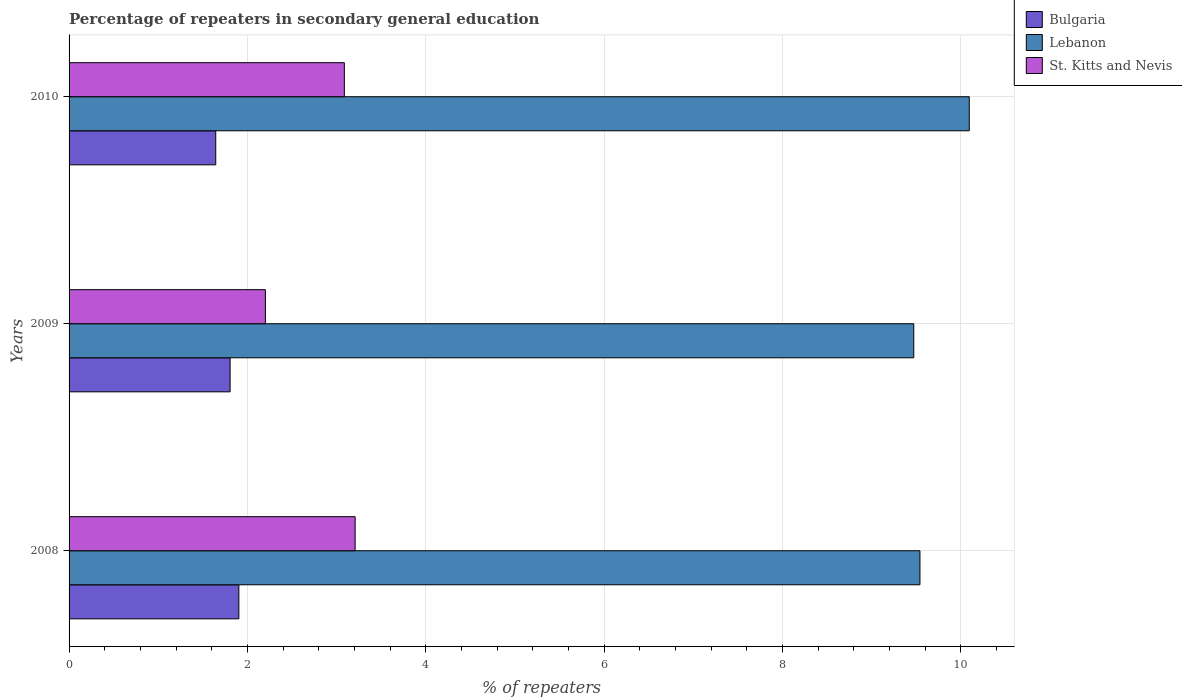Are the number of bars per tick equal to the number of legend labels?
Your answer should be compact. Yes. Are the number of bars on each tick of the Y-axis equal?
Your answer should be compact. Yes. What is the percentage of repeaters in secondary general education in Lebanon in 2008?
Ensure brevity in your answer.  9.54. Across all years, what is the maximum percentage of repeaters in secondary general education in Lebanon?
Your response must be concise. 10.09. Across all years, what is the minimum percentage of repeaters in secondary general education in Lebanon?
Offer a terse response. 9.47. In which year was the percentage of repeaters in secondary general education in Lebanon maximum?
Ensure brevity in your answer.  2010. In which year was the percentage of repeaters in secondary general education in Lebanon minimum?
Your answer should be very brief. 2009. What is the total percentage of repeaters in secondary general education in St. Kitts and Nevis in the graph?
Offer a very short reply. 8.5. What is the difference between the percentage of repeaters in secondary general education in Lebanon in 2008 and that in 2010?
Make the answer very short. -0.55. What is the difference between the percentage of repeaters in secondary general education in Lebanon in 2010 and the percentage of repeaters in secondary general education in St. Kitts and Nevis in 2009?
Provide a succinct answer. 7.89. What is the average percentage of repeaters in secondary general education in Bulgaria per year?
Provide a short and direct response. 1.78. In the year 2009, what is the difference between the percentage of repeaters in secondary general education in Lebanon and percentage of repeaters in secondary general education in Bulgaria?
Your response must be concise. 7.67. What is the ratio of the percentage of repeaters in secondary general education in Bulgaria in 2009 to that in 2010?
Keep it short and to the point. 1.1. Is the percentage of repeaters in secondary general education in Bulgaria in 2009 less than that in 2010?
Provide a short and direct response. No. What is the difference between the highest and the second highest percentage of repeaters in secondary general education in Bulgaria?
Provide a succinct answer. 0.1. What is the difference between the highest and the lowest percentage of repeaters in secondary general education in Lebanon?
Your answer should be compact. 0.62. In how many years, is the percentage of repeaters in secondary general education in St. Kitts and Nevis greater than the average percentage of repeaters in secondary general education in St. Kitts and Nevis taken over all years?
Your answer should be very brief. 2. Is the sum of the percentage of repeaters in secondary general education in Bulgaria in 2008 and 2009 greater than the maximum percentage of repeaters in secondary general education in Lebanon across all years?
Give a very brief answer. No. What does the 3rd bar from the top in 2010 represents?
Your response must be concise. Bulgaria. What does the 3rd bar from the bottom in 2008 represents?
Offer a very short reply. St. Kitts and Nevis. Is it the case that in every year, the sum of the percentage of repeaters in secondary general education in Bulgaria and percentage of repeaters in secondary general education in Lebanon is greater than the percentage of repeaters in secondary general education in St. Kitts and Nevis?
Keep it short and to the point. Yes. How many bars are there?
Your answer should be compact. 9. Are all the bars in the graph horizontal?
Provide a succinct answer. Yes. Are the values on the major ticks of X-axis written in scientific E-notation?
Provide a succinct answer. No. Does the graph contain any zero values?
Make the answer very short. No. Where does the legend appear in the graph?
Offer a terse response. Top right. What is the title of the graph?
Give a very brief answer. Percentage of repeaters in secondary general education. What is the label or title of the X-axis?
Offer a terse response. % of repeaters. What is the label or title of the Y-axis?
Make the answer very short. Years. What is the % of repeaters of Bulgaria in 2008?
Your response must be concise. 1.9. What is the % of repeaters in Lebanon in 2008?
Offer a terse response. 9.54. What is the % of repeaters in St. Kitts and Nevis in 2008?
Make the answer very short. 3.21. What is the % of repeaters in Bulgaria in 2009?
Give a very brief answer. 1.81. What is the % of repeaters in Lebanon in 2009?
Your response must be concise. 9.47. What is the % of repeaters in St. Kitts and Nevis in 2009?
Make the answer very short. 2.2. What is the % of repeaters of Bulgaria in 2010?
Give a very brief answer. 1.64. What is the % of repeaters of Lebanon in 2010?
Provide a succinct answer. 10.09. What is the % of repeaters of St. Kitts and Nevis in 2010?
Make the answer very short. 3.09. Across all years, what is the maximum % of repeaters of Bulgaria?
Offer a very short reply. 1.9. Across all years, what is the maximum % of repeaters in Lebanon?
Give a very brief answer. 10.09. Across all years, what is the maximum % of repeaters of St. Kitts and Nevis?
Make the answer very short. 3.21. Across all years, what is the minimum % of repeaters in Bulgaria?
Your answer should be compact. 1.64. Across all years, what is the minimum % of repeaters in Lebanon?
Your answer should be compact. 9.47. Across all years, what is the minimum % of repeaters in St. Kitts and Nevis?
Your answer should be very brief. 2.2. What is the total % of repeaters in Bulgaria in the graph?
Your answer should be very brief. 5.35. What is the total % of repeaters in Lebanon in the graph?
Provide a succinct answer. 29.11. What is the total % of repeaters of St. Kitts and Nevis in the graph?
Your answer should be compact. 8.5. What is the difference between the % of repeaters in Bulgaria in 2008 and that in 2009?
Your response must be concise. 0.1. What is the difference between the % of repeaters of Lebanon in 2008 and that in 2009?
Keep it short and to the point. 0.07. What is the difference between the % of repeaters in Bulgaria in 2008 and that in 2010?
Give a very brief answer. 0.26. What is the difference between the % of repeaters of Lebanon in 2008 and that in 2010?
Your answer should be very brief. -0.55. What is the difference between the % of repeaters in St. Kitts and Nevis in 2008 and that in 2010?
Keep it short and to the point. 0.12. What is the difference between the % of repeaters in Bulgaria in 2009 and that in 2010?
Keep it short and to the point. 0.16. What is the difference between the % of repeaters in Lebanon in 2009 and that in 2010?
Ensure brevity in your answer.  -0.62. What is the difference between the % of repeaters of St. Kitts and Nevis in 2009 and that in 2010?
Ensure brevity in your answer.  -0.89. What is the difference between the % of repeaters in Bulgaria in 2008 and the % of repeaters in Lebanon in 2009?
Provide a succinct answer. -7.57. What is the difference between the % of repeaters of Bulgaria in 2008 and the % of repeaters of St. Kitts and Nevis in 2009?
Provide a succinct answer. -0.3. What is the difference between the % of repeaters of Lebanon in 2008 and the % of repeaters of St. Kitts and Nevis in 2009?
Your response must be concise. 7.34. What is the difference between the % of repeaters in Bulgaria in 2008 and the % of repeaters in Lebanon in 2010?
Your response must be concise. -8.19. What is the difference between the % of repeaters in Bulgaria in 2008 and the % of repeaters in St. Kitts and Nevis in 2010?
Your answer should be compact. -1.18. What is the difference between the % of repeaters of Lebanon in 2008 and the % of repeaters of St. Kitts and Nevis in 2010?
Ensure brevity in your answer.  6.45. What is the difference between the % of repeaters of Bulgaria in 2009 and the % of repeaters of Lebanon in 2010?
Your response must be concise. -8.29. What is the difference between the % of repeaters of Bulgaria in 2009 and the % of repeaters of St. Kitts and Nevis in 2010?
Your response must be concise. -1.28. What is the difference between the % of repeaters of Lebanon in 2009 and the % of repeaters of St. Kitts and Nevis in 2010?
Provide a short and direct response. 6.38. What is the average % of repeaters in Bulgaria per year?
Provide a short and direct response. 1.78. What is the average % of repeaters in Lebanon per year?
Offer a very short reply. 9.7. What is the average % of repeaters in St. Kitts and Nevis per year?
Provide a succinct answer. 2.83. In the year 2008, what is the difference between the % of repeaters in Bulgaria and % of repeaters in Lebanon?
Make the answer very short. -7.64. In the year 2008, what is the difference between the % of repeaters in Bulgaria and % of repeaters in St. Kitts and Nevis?
Your answer should be compact. -1.3. In the year 2008, what is the difference between the % of repeaters of Lebanon and % of repeaters of St. Kitts and Nevis?
Give a very brief answer. 6.33. In the year 2009, what is the difference between the % of repeaters in Bulgaria and % of repeaters in Lebanon?
Keep it short and to the point. -7.67. In the year 2009, what is the difference between the % of repeaters of Bulgaria and % of repeaters of St. Kitts and Nevis?
Ensure brevity in your answer.  -0.4. In the year 2009, what is the difference between the % of repeaters of Lebanon and % of repeaters of St. Kitts and Nevis?
Make the answer very short. 7.27. In the year 2010, what is the difference between the % of repeaters in Bulgaria and % of repeaters in Lebanon?
Provide a succinct answer. -8.45. In the year 2010, what is the difference between the % of repeaters in Bulgaria and % of repeaters in St. Kitts and Nevis?
Offer a terse response. -1.44. In the year 2010, what is the difference between the % of repeaters in Lebanon and % of repeaters in St. Kitts and Nevis?
Offer a very short reply. 7.01. What is the ratio of the % of repeaters of Bulgaria in 2008 to that in 2009?
Provide a short and direct response. 1.05. What is the ratio of the % of repeaters of Lebanon in 2008 to that in 2009?
Offer a terse response. 1.01. What is the ratio of the % of repeaters in St. Kitts and Nevis in 2008 to that in 2009?
Make the answer very short. 1.46. What is the ratio of the % of repeaters of Bulgaria in 2008 to that in 2010?
Keep it short and to the point. 1.16. What is the ratio of the % of repeaters of Lebanon in 2008 to that in 2010?
Offer a very short reply. 0.95. What is the ratio of the % of repeaters of St. Kitts and Nevis in 2008 to that in 2010?
Keep it short and to the point. 1.04. What is the ratio of the % of repeaters of Bulgaria in 2009 to that in 2010?
Give a very brief answer. 1.1. What is the ratio of the % of repeaters of Lebanon in 2009 to that in 2010?
Keep it short and to the point. 0.94. What is the ratio of the % of repeaters in St. Kitts and Nevis in 2009 to that in 2010?
Provide a succinct answer. 0.71. What is the difference between the highest and the second highest % of repeaters of Bulgaria?
Ensure brevity in your answer.  0.1. What is the difference between the highest and the second highest % of repeaters of Lebanon?
Offer a very short reply. 0.55. What is the difference between the highest and the second highest % of repeaters of St. Kitts and Nevis?
Provide a succinct answer. 0.12. What is the difference between the highest and the lowest % of repeaters of Bulgaria?
Provide a succinct answer. 0.26. What is the difference between the highest and the lowest % of repeaters in Lebanon?
Ensure brevity in your answer.  0.62. 